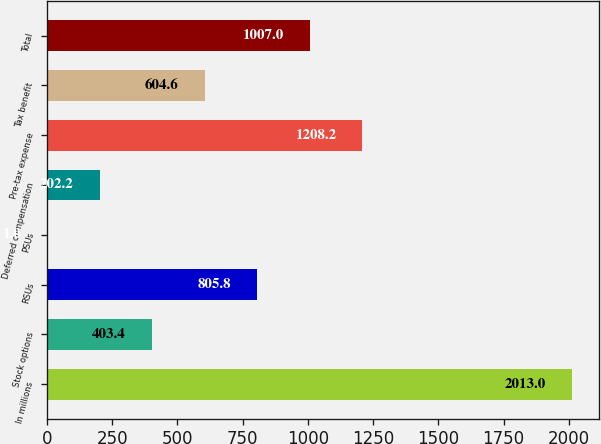Convert chart. <chart><loc_0><loc_0><loc_500><loc_500><bar_chart><fcel>In millions<fcel>Stock options<fcel>RSUs<fcel>PSUs<fcel>Deferred compensation<fcel>Pre-tax expense<fcel>Tax benefit<fcel>Total<nl><fcel>2013<fcel>403.4<fcel>805.8<fcel>1<fcel>202.2<fcel>1208.2<fcel>604.6<fcel>1007<nl></chart> 